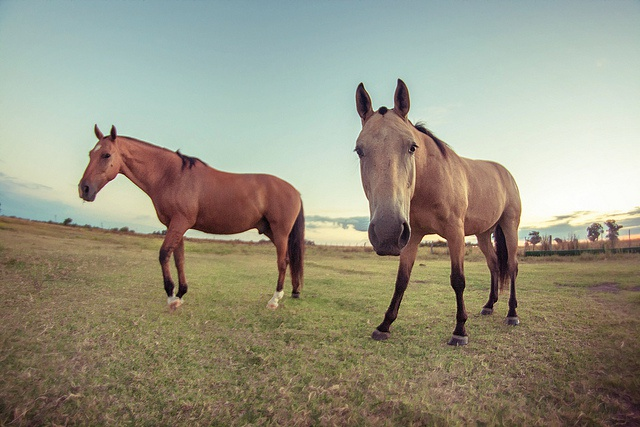Describe the objects in this image and their specific colors. I can see horse in darkgray, gray, tan, brown, and black tones and horse in darkgray, brown, maroon, and black tones in this image. 